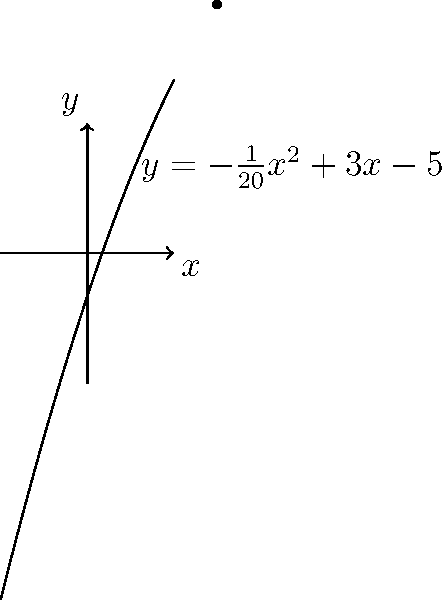As a parent volunteering at Las Americas Newcomer School's fundraising event, you're in charge of designing a parabolic arch for the entrance. The arch is represented by the function $y = -\frac{1}{20}x^2 + 3x - 5$, where $x$ and $y$ are measured in feet. What is the maximum height of the arch, and at what horizontal position does it occur? To find the maximum height of the parabolic arch, we need to find the vertex of the parabola. For a quadratic function in the form $f(x) = ax^2 + bx + c$, the x-coordinate of the vertex is given by $x = -\frac{b}{2a}$.

Step 1: Identify $a$ and $b$ from the given function.
$y = -\frac{1}{20}x^2 + 3x - 5$
$a = -\frac{1}{20}$ and $b = 3$

Step 2: Calculate the x-coordinate of the vertex.
$x = -\frac{b}{2a} = -\frac{3}{2(-\frac{1}{20})} = 30$ feet

Step 3: Find the y-coordinate (maximum height) by plugging the x-value into the original function.
$y = -\frac{1}{20}(30)^2 + 3(30) - 5$
$y = -45 + 90 - 5 = 40$ feet

Therefore, the maximum height of the arch is 40 feet, occurring at a horizontal position of 30 feet from the origin.
Answer: Maximum height: 40 feet; Horizontal position: 30 feet 